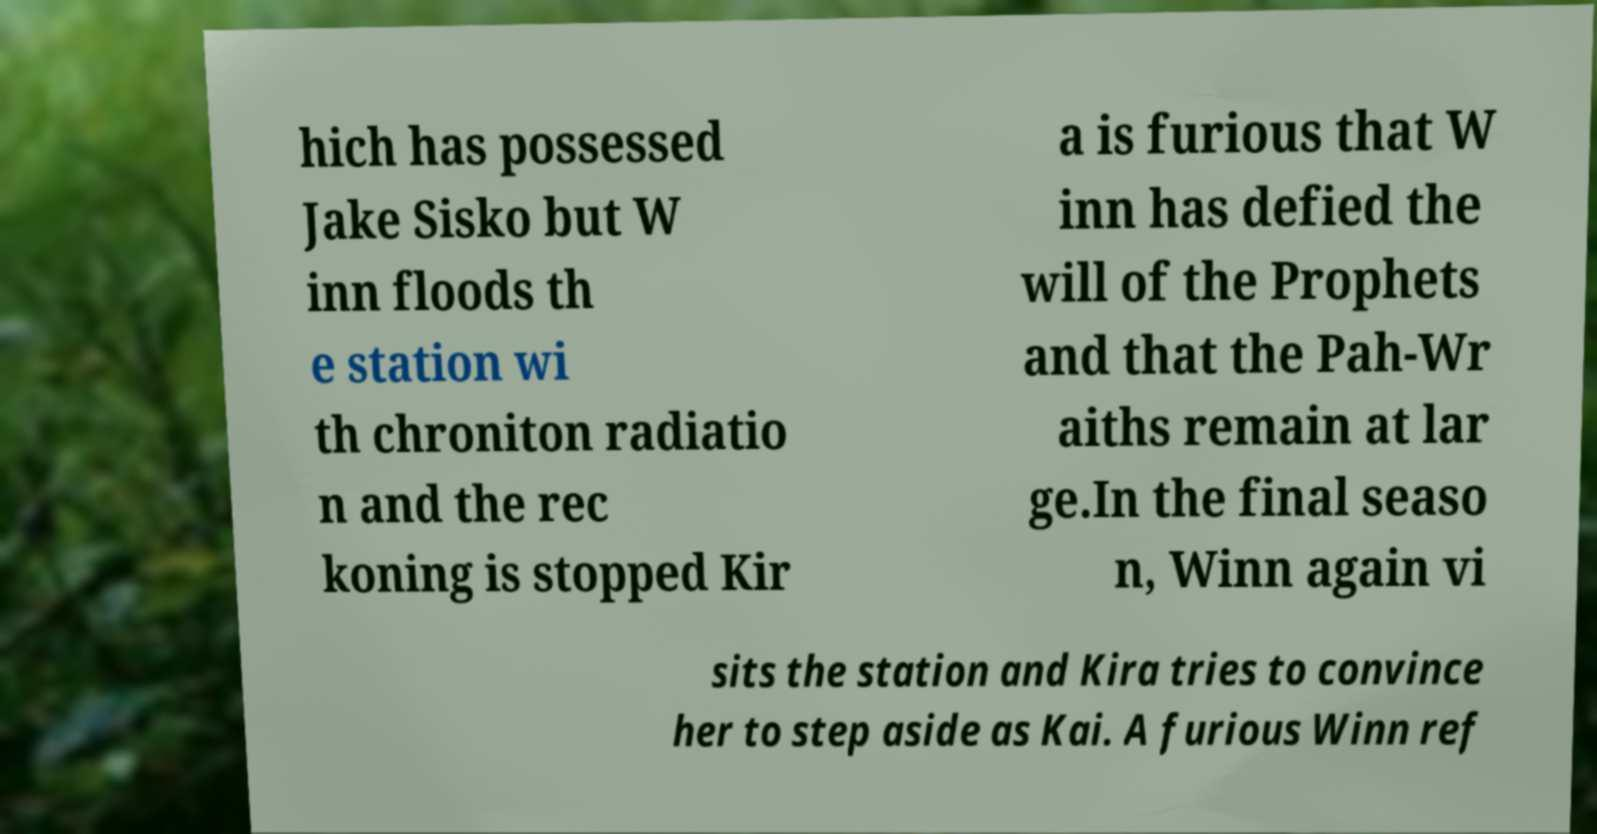Please read and relay the text visible in this image. What does it say? hich has possessed Jake Sisko but W inn floods th e station wi th chroniton radiatio n and the rec koning is stopped Kir a is furious that W inn has defied the will of the Prophets and that the Pah-Wr aiths remain at lar ge.In the final seaso n, Winn again vi sits the station and Kira tries to convince her to step aside as Kai. A furious Winn ref 